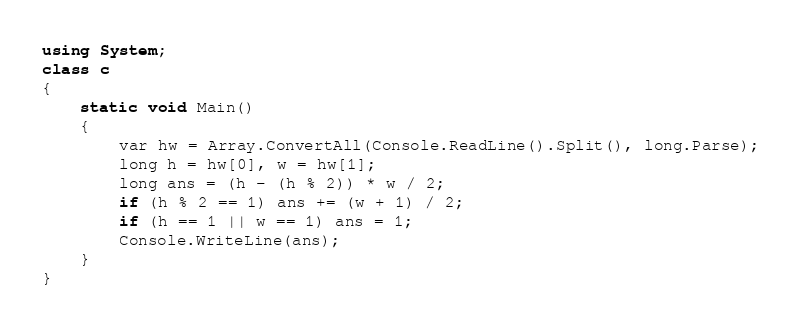Convert code to text. <code><loc_0><loc_0><loc_500><loc_500><_C#_>using System;
class c
{
    static void Main()
    {
        var hw = Array.ConvertAll(Console.ReadLine().Split(), long.Parse);
        long h = hw[0], w = hw[1];
        long ans = (h - (h % 2)) * w / 2;
        if (h % 2 == 1) ans += (w + 1) / 2;
        if (h == 1 || w == 1) ans = 1;
        Console.WriteLine(ans);
    }
}
</code> 